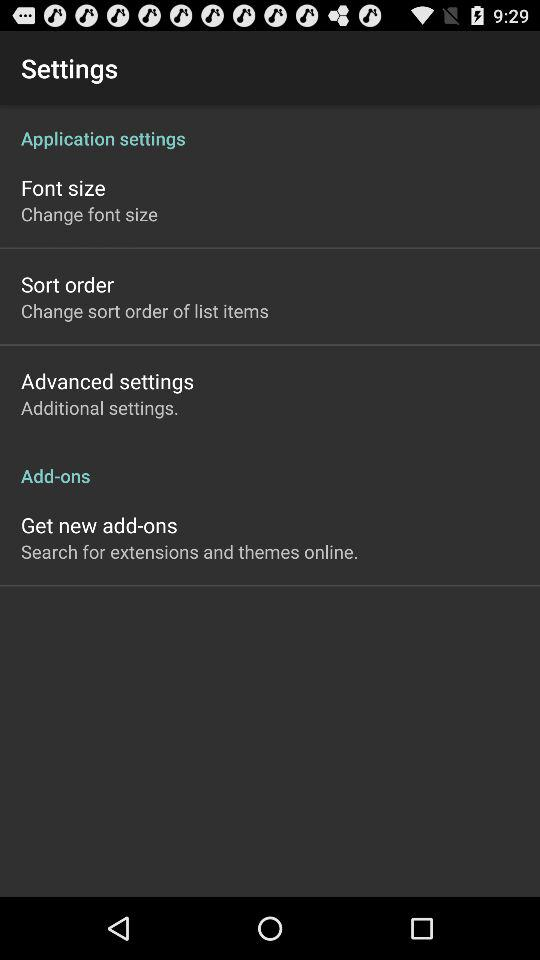How many more items are in the Application settings section than the Add-ons section?
Answer the question using a single word or phrase. 2 